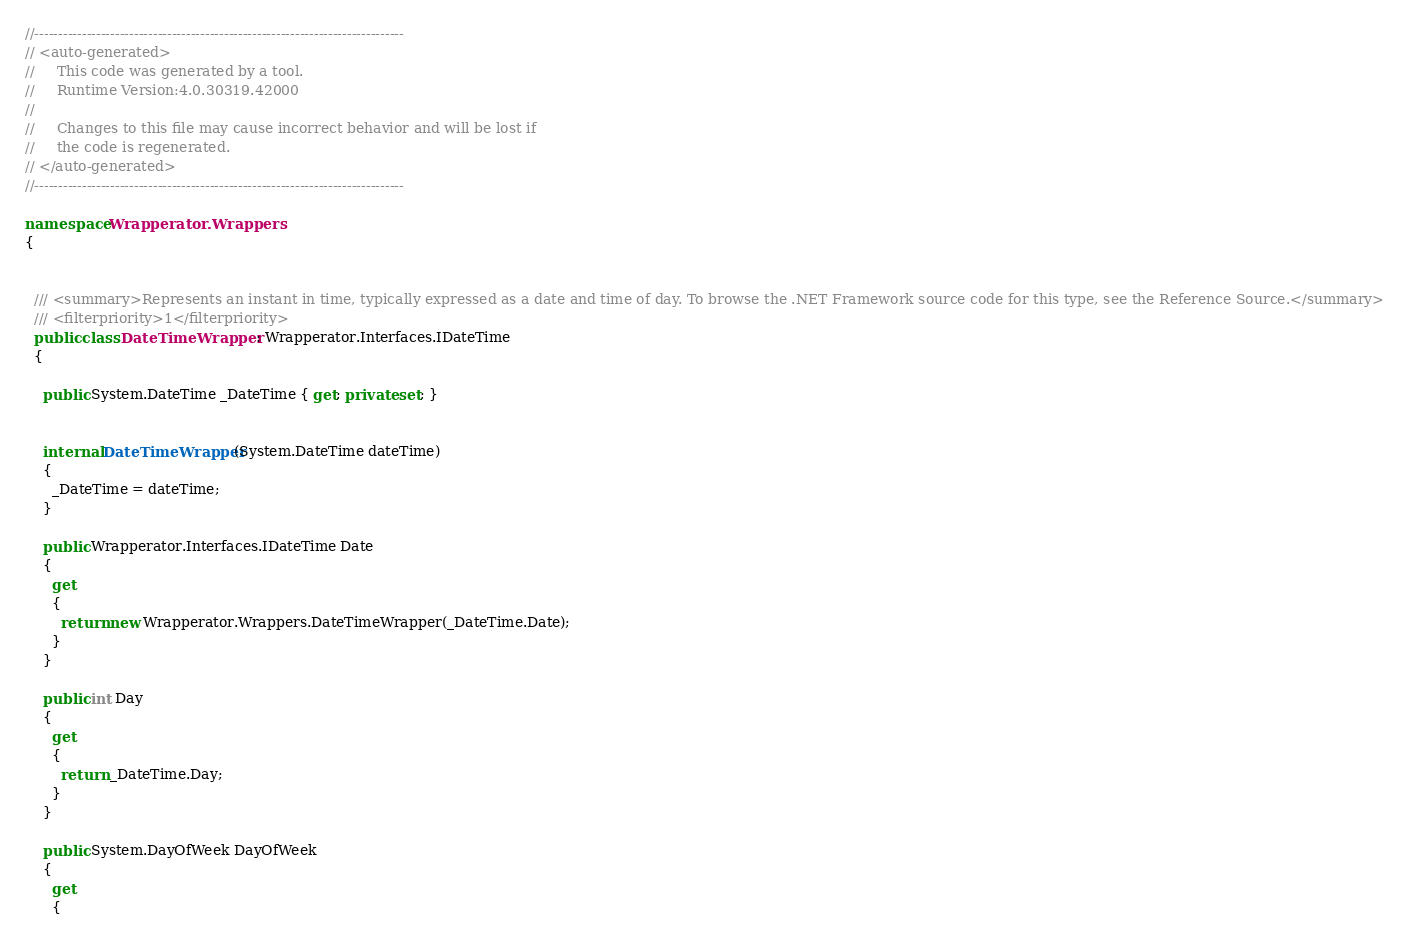Convert code to text. <code><loc_0><loc_0><loc_500><loc_500><_C#_>//------------------------------------------------------------------------------
// <auto-generated>
//     This code was generated by a tool.
//     Runtime Version:4.0.30319.42000
//
//     Changes to this file may cause incorrect behavior and will be lost if
//     the code is regenerated.
// </auto-generated>
//------------------------------------------------------------------------------

namespace Wrapperator.Wrappers
{
  
  
  /// <summary>Represents an instant in time, typically expressed as a date and time of day. To browse the .NET Framework source code for this type, see the Reference Source.</summary>
  /// <filterpriority>1</filterpriority>
  public class DateTimeWrapper : Wrapperator.Interfaces.IDateTime
  {
    
    public System.DateTime _DateTime { get; private set; }

    
    internal DateTimeWrapper(System.DateTime dateTime)
    {
      _DateTime = dateTime;
    }
    
    public Wrapperator.Interfaces.IDateTime Date
    {
      get
      {
        return new Wrapperator.Wrappers.DateTimeWrapper(_DateTime.Date);
      }
    }
    
    public int Day
    {
      get
      {
        return _DateTime.Day;
      }
    }
    
    public System.DayOfWeek DayOfWeek
    {
      get
      {</code> 